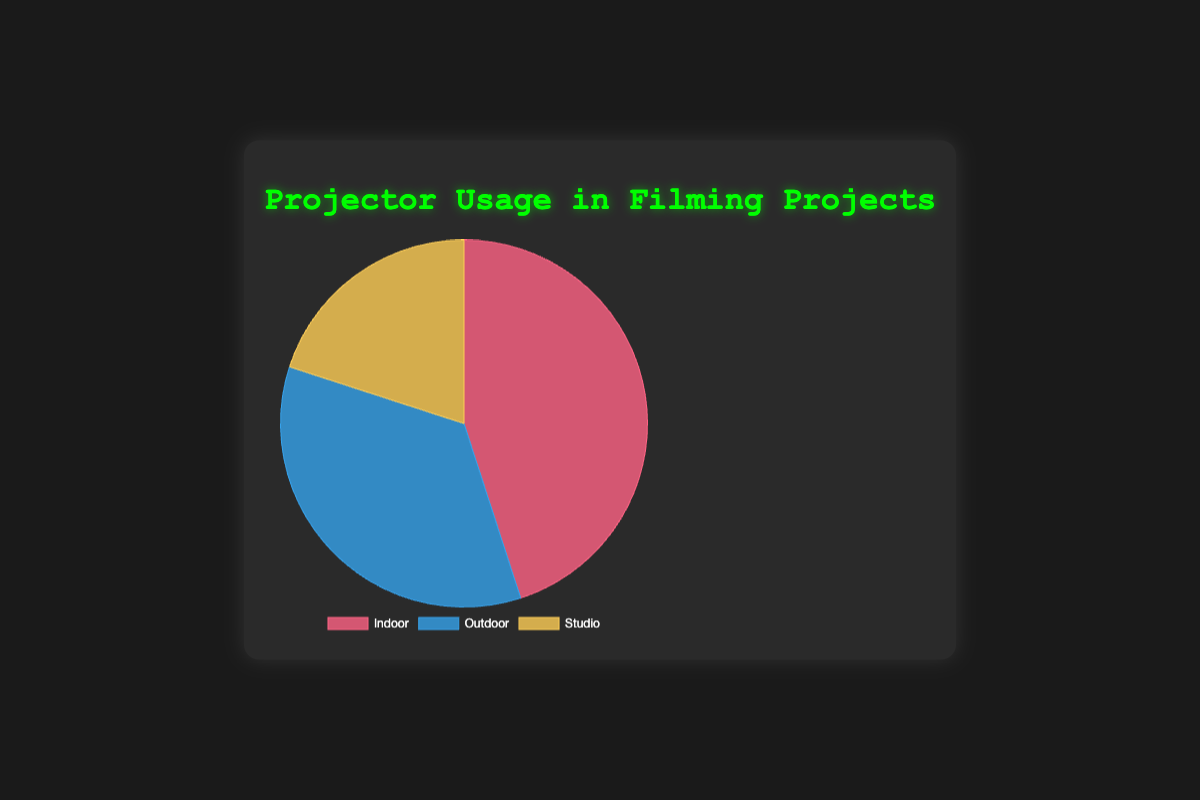Which projector usage setting has the highest percentage? To determine which projector usage setting has the highest percentage, look at the pie chart slices and identify the one with the largest size. Based on the chart, "Indoor" has the largest slice, which corresponds to 45%.
Answer: Indoor Which projector usage setting has the smallest percentage? To determine which projector usage setting has the smallest percentage, look for the smallest slice in the pie chart. "Studio" is the smallest slice, corresponding to 20%.
Answer: Studio What is the total percentage of outdoor and studio projector usage settings combined? To find the combined total percentage, add the percentages for "Outdoor" and "Studio" settings. "Outdoor" is 35% and "Studio" is 20%. Therefore, 35 + 20 = 55%.
Answer: 55% Which two projector usage settings have a combined percentage greater than Indoor usage? To determine which combinations of two settings have a combined percentage higher than the "Indoor" setting's 45%, we check the other settings. The combined percentage of "Outdoor" (35%) and "Studio" (20%) is 55%, which is greater than 45%. Therefore, Outdoor and Studio combined have a greater percentage than Indoor.
Answer: Outdoor and Studio What is the difference in percentage between Indoor and Outdoor projector usage settings? To determine the difference in percentage between "Indoor" and "Outdoor" settings, subtract the smaller percentage (Outdoor) from the larger one (Indoor). So, 45% - 35% = 10%.
Answer: 10% If you were to add the percentage of Studio projector usage setting to itself, would it be greater than Outdoor projector usage setting? Double the percentage of the "Studio" setting and compare it to the "Outdoor" setting. Doubling Studio's 20% results in 40%, which is greater than Outdoor's 35%.
Answer: Yes What color represents the "Studio" projector usage setting in the chart? To identify the color representing "Studio" in the pie chart, observe the color block corresponding to "Studio." The "Studio" slice is light yellow.
Answer: Yellow How much more percentage does Indoor projector usage setting have compared to Studio projector usage setting? To find how much more percentage the "Indoor" setting has compared to the "Studio" setting, subtract the percentage of "Studio" from the percentage of "Indoor." So, 45% - 20% = 25%.
Answer: 25% If the pie chart had a fourth category "Virtual" with 15%, how would the "Studio" percentage compare with it? Compare the given percentage of the new category "Virtual" with the "Studio" setting's percentage. "Studio" has 20%, which is more than the new "Virtual" category's 15%.
Answer: More 